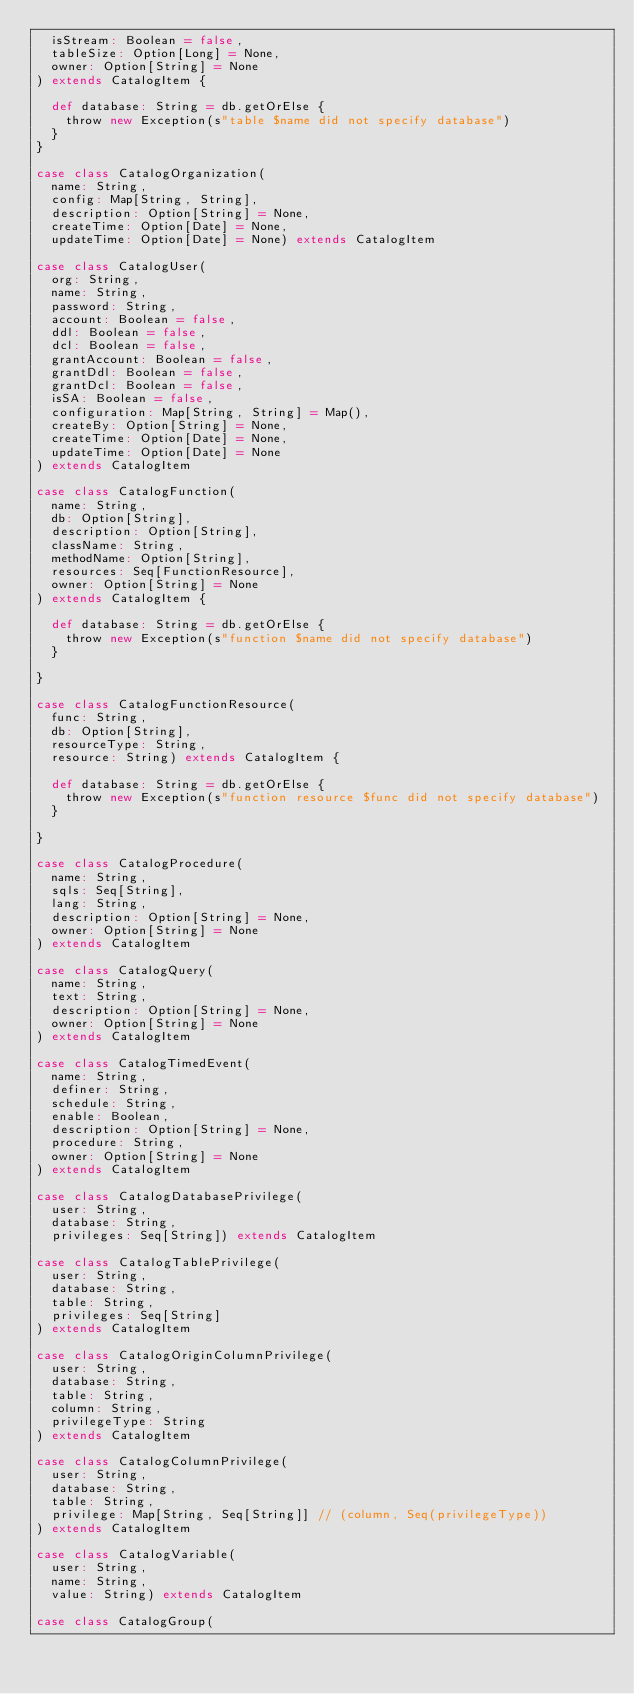<code> <loc_0><loc_0><loc_500><loc_500><_Scala_>	isStream: Boolean = false,
	tableSize: Option[Long] = None,
	owner: Option[String] = None
) extends CatalogItem {

	def database: String = db.getOrElse {
		throw new Exception(s"table $name did not specify database")
	}
}

case class CatalogOrganization(
	name: String,
	config: Map[String, String],
	description: Option[String] = None,
	createTime: Option[Date] = None,
	updateTime: Option[Date] = None) extends CatalogItem

case class CatalogUser(
	org: String,
	name: String,
	password: String,
	account: Boolean = false,
	ddl: Boolean = false,
	dcl: Boolean = false,
	grantAccount: Boolean = false,
	grantDdl: Boolean = false,
	grantDcl: Boolean = false,
	isSA: Boolean = false,
	configuration: Map[String, String] = Map(),
	createBy: Option[String] = None,
	createTime: Option[Date] = None,
	updateTime: Option[Date] = None
) extends CatalogItem

case class CatalogFunction(
	name: String,
	db: Option[String],
	description: Option[String],
	className: String,
	methodName: Option[String],
	resources: Seq[FunctionResource],
	owner: Option[String] = None
) extends CatalogItem {

	def database: String = db.getOrElse {
		throw new Exception(s"function $name did not specify database")
	}

}

case class CatalogFunctionResource(
	func: String,
	db: Option[String],
	resourceType: String,
	resource: String) extends CatalogItem {

	def database: String = db.getOrElse {
		throw new Exception(s"function resource $func did not specify database")
	}

}

case class CatalogProcedure(
	name: String,
	sqls: Seq[String],
	lang: String,
	description: Option[String] = None,
	owner: Option[String] = None
) extends CatalogItem

case class CatalogQuery(
	name: String,
	text: String,
	description: Option[String] = None,
	owner: Option[String] = None
) extends CatalogItem

case class CatalogTimedEvent(
	name: String,
	definer: String,
	schedule: String,
	enable: Boolean,
	description: Option[String] = None,
	procedure: String,
	owner: Option[String] = None
) extends CatalogItem

case class CatalogDatabasePrivilege(
	user: String,
	database: String,
	privileges: Seq[String]) extends CatalogItem

case class CatalogTablePrivilege(
	user: String,
	database: String,
	table: String,
	privileges: Seq[String]
) extends CatalogItem

case class CatalogOriginColumnPrivilege(
	user: String,
	database: String,
	table: String,
	column: String,
	privilegeType: String
) extends CatalogItem

case class CatalogColumnPrivilege(
	user: String,
	database: String,
	table: String,
	privilege: Map[String, Seq[String]] // (column, Seq(privilegeType))
) extends CatalogItem

case class CatalogVariable(
	user: String,
	name: String,
	value: String) extends CatalogItem

case class CatalogGroup(</code> 